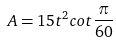<formula> <loc_0><loc_0><loc_500><loc_500>A = 1 5 t ^ { 2 } c o t \frac { \pi } { 6 0 }</formula> 